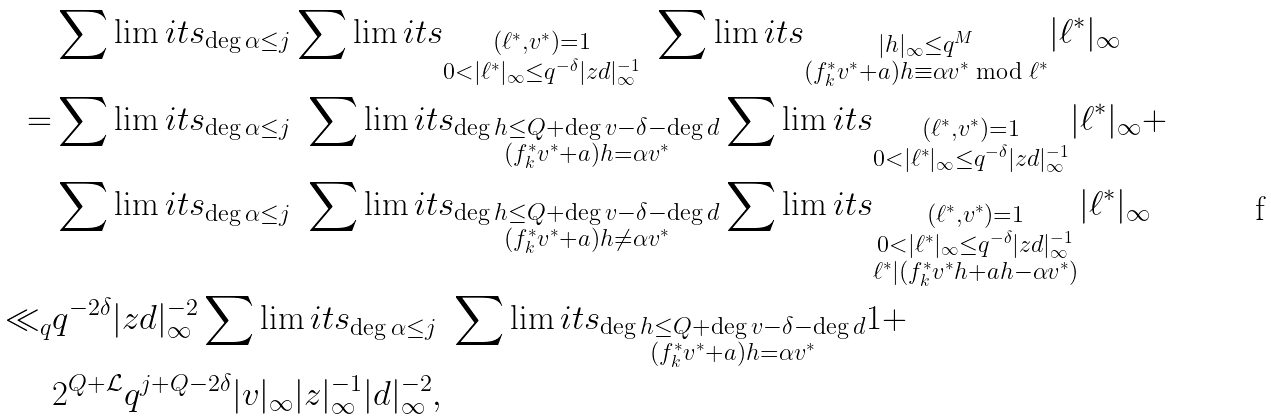<formula> <loc_0><loc_0><loc_500><loc_500>& \sum \lim i t s _ { \deg \alpha \leq j } \sum \lim i t s _ { \substack { ( \ell ^ { \ast } , v ^ { \ast } ) = 1 \\ 0 < | \ell ^ { \ast } | _ { \infty } \leq q ^ { - \delta } | z d | _ { \infty } ^ { - 1 } } } \ \sum \lim i t s _ { \substack { | h | _ { \infty } \leq q ^ { M } \\ ( f _ { k } ^ { \ast } v ^ { \ast } + a ) h \equiv \alpha v ^ { \ast } \bmod { \ell ^ { \ast } } } } | \ell ^ { \ast } | _ { \infty } \\ = & \sum \lim i t s _ { \deg \alpha \leq j } \ \sum \lim i t s _ { \substack { \deg h \leq Q + \deg v - \delta - \deg d \\ ( f _ { k } ^ { \ast } v ^ { \ast } + a ) h = \alpha v ^ { \ast } } } \sum \lim i t s _ { \substack { ( \ell ^ { \ast } , v ^ { \ast } ) = 1 \\ 0 < | \ell ^ { \ast } | _ { \infty } \leq q ^ { - \delta } | z d | _ { \infty } ^ { - 1 } } } | \ell ^ { \ast } | _ { \infty } + \\ & \sum \lim i t s _ { \deg \alpha \leq j } \ \sum \lim i t s _ { \substack { \deg h \leq Q + \deg v - \delta - \deg d \\ ( f _ { k } ^ { \ast } v ^ { \ast } + a ) h \not = \alpha v ^ { \ast } } } \sum \lim i t s _ { \substack { ( \ell ^ { \ast } , v ^ { \ast } ) = 1 \\ 0 < | \ell ^ { \ast } | _ { \infty } \leq q ^ { - \delta } | z d | _ { \infty } ^ { - 1 } \\ \ell ^ { \ast } | ( f _ { k } ^ { \ast } v ^ { \ast } h + a h - \alpha v ^ { \ast } ) } } | \ell ^ { \ast } | _ { \infty } \\ \ll _ { q } & q ^ { - 2 \delta } | z d | _ { \infty } ^ { - 2 } \sum \lim i t s _ { \deg \alpha \leq j } \ \sum \lim i t s _ { \substack { \deg h \leq Q + \deg v - \delta - \deg d \\ ( f _ { k } ^ { \ast } v ^ { \ast } + a ) h = \alpha v ^ { \ast } } } 1 + \\ & 2 ^ { Q + \mathcal { L } } q ^ { j + Q - 2 \delta } | v | _ { \infty } | z | _ { \infty } ^ { - 1 } | d | _ { \infty } ^ { - 2 } ,</formula> 